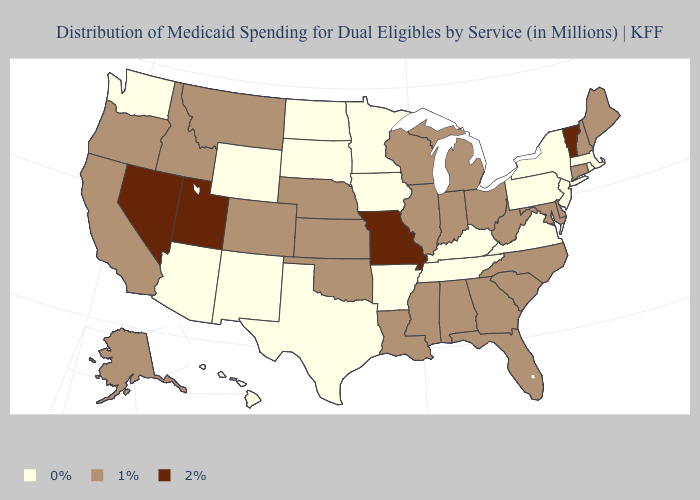Does South Dakota have the highest value in the MidWest?
Short answer required. No. Name the states that have a value in the range 0%?
Concise answer only. Arizona, Arkansas, Hawaii, Iowa, Kentucky, Massachusetts, Minnesota, New Jersey, New Mexico, New York, North Dakota, Pennsylvania, Rhode Island, South Dakota, Tennessee, Texas, Virginia, Washington, Wyoming. Does the first symbol in the legend represent the smallest category?
Keep it brief. Yes. Name the states that have a value in the range 2%?
Short answer required. Missouri, Nevada, Utah, Vermont. Does Ohio have a lower value than Vermont?
Answer briefly. Yes. Does Utah have the lowest value in the USA?
Short answer required. No. Name the states that have a value in the range 2%?
Keep it brief. Missouri, Nevada, Utah, Vermont. What is the value of Michigan?
Concise answer only. 1%. Does North Carolina have a lower value than Utah?
Quick response, please. Yes. How many symbols are there in the legend?
Keep it brief. 3. Name the states that have a value in the range 2%?
Quick response, please. Missouri, Nevada, Utah, Vermont. Does South Carolina have a higher value than New Hampshire?
Short answer required. No. Among the states that border Oregon , which have the highest value?
Answer briefly. Nevada. Does Michigan have the lowest value in the MidWest?
Concise answer only. No. Name the states that have a value in the range 1%?
Give a very brief answer. Alabama, Alaska, California, Colorado, Connecticut, Delaware, Florida, Georgia, Idaho, Illinois, Indiana, Kansas, Louisiana, Maine, Maryland, Michigan, Mississippi, Montana, Nebraska, New Hampshire, North Carolina, Ohio, Oklahoma, Oregon, South Carolina, West Virginia, Wisconsin. 